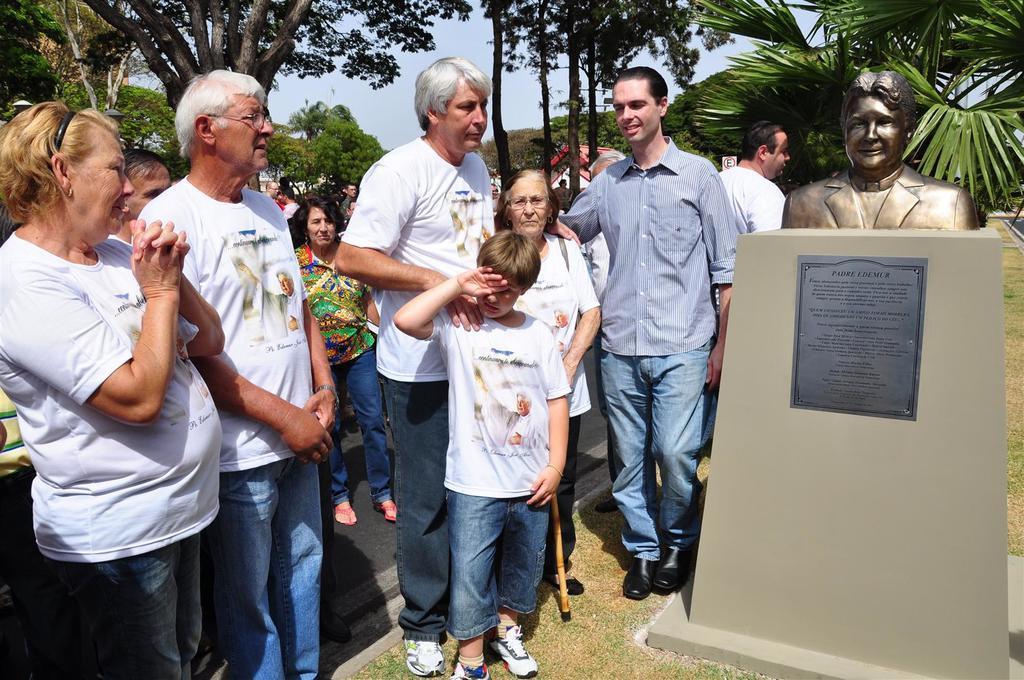Could you give a brief overview of what you see in this image? This is an outside view. On the right side, I can see a memorial on which I can see a statue of a person. Beside this there are few people standing and looking at this memorial. In the background there are some trees. On the top of the image I can see the sky. 